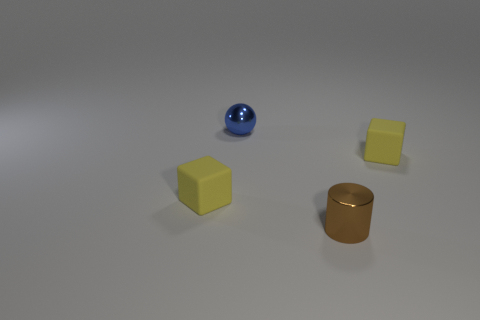Subtract all spheres. How many objects are left? 3 Add 3 blue matte cylinders. How many objects exist? 7 Subtract 0 gray spheres. How many objects are left? 4 Subtract all brown cylinders. Subtract all small brown metal things. How many objects are left? 2 Add 1 small yellow rubber blocks. How many small yellow rubber blocks are left? 3 Add 4 small shiny cylinders. How many small shiny cylinders exist? 5 